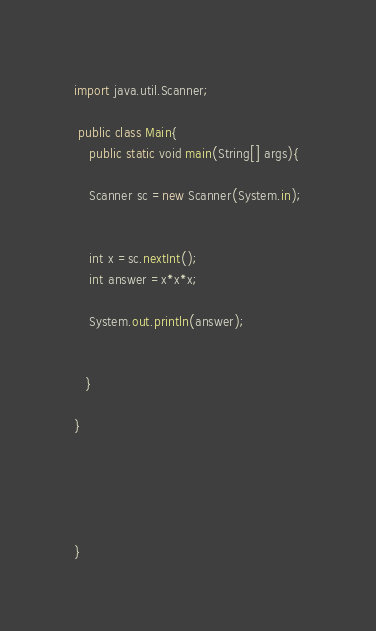<code> <loc_0><loc_0><loc_500><loc_500><_Java_>import java.util.Scanner;

 public class Main{
    public static void main(String[] args){
    
    Scanner sc =new Scanner(System.in);

    
    int x =sc.nextInt();
    int answer =x*x*x;

    System.out.println(answer);
 
  
   }
   
}





}</code> 